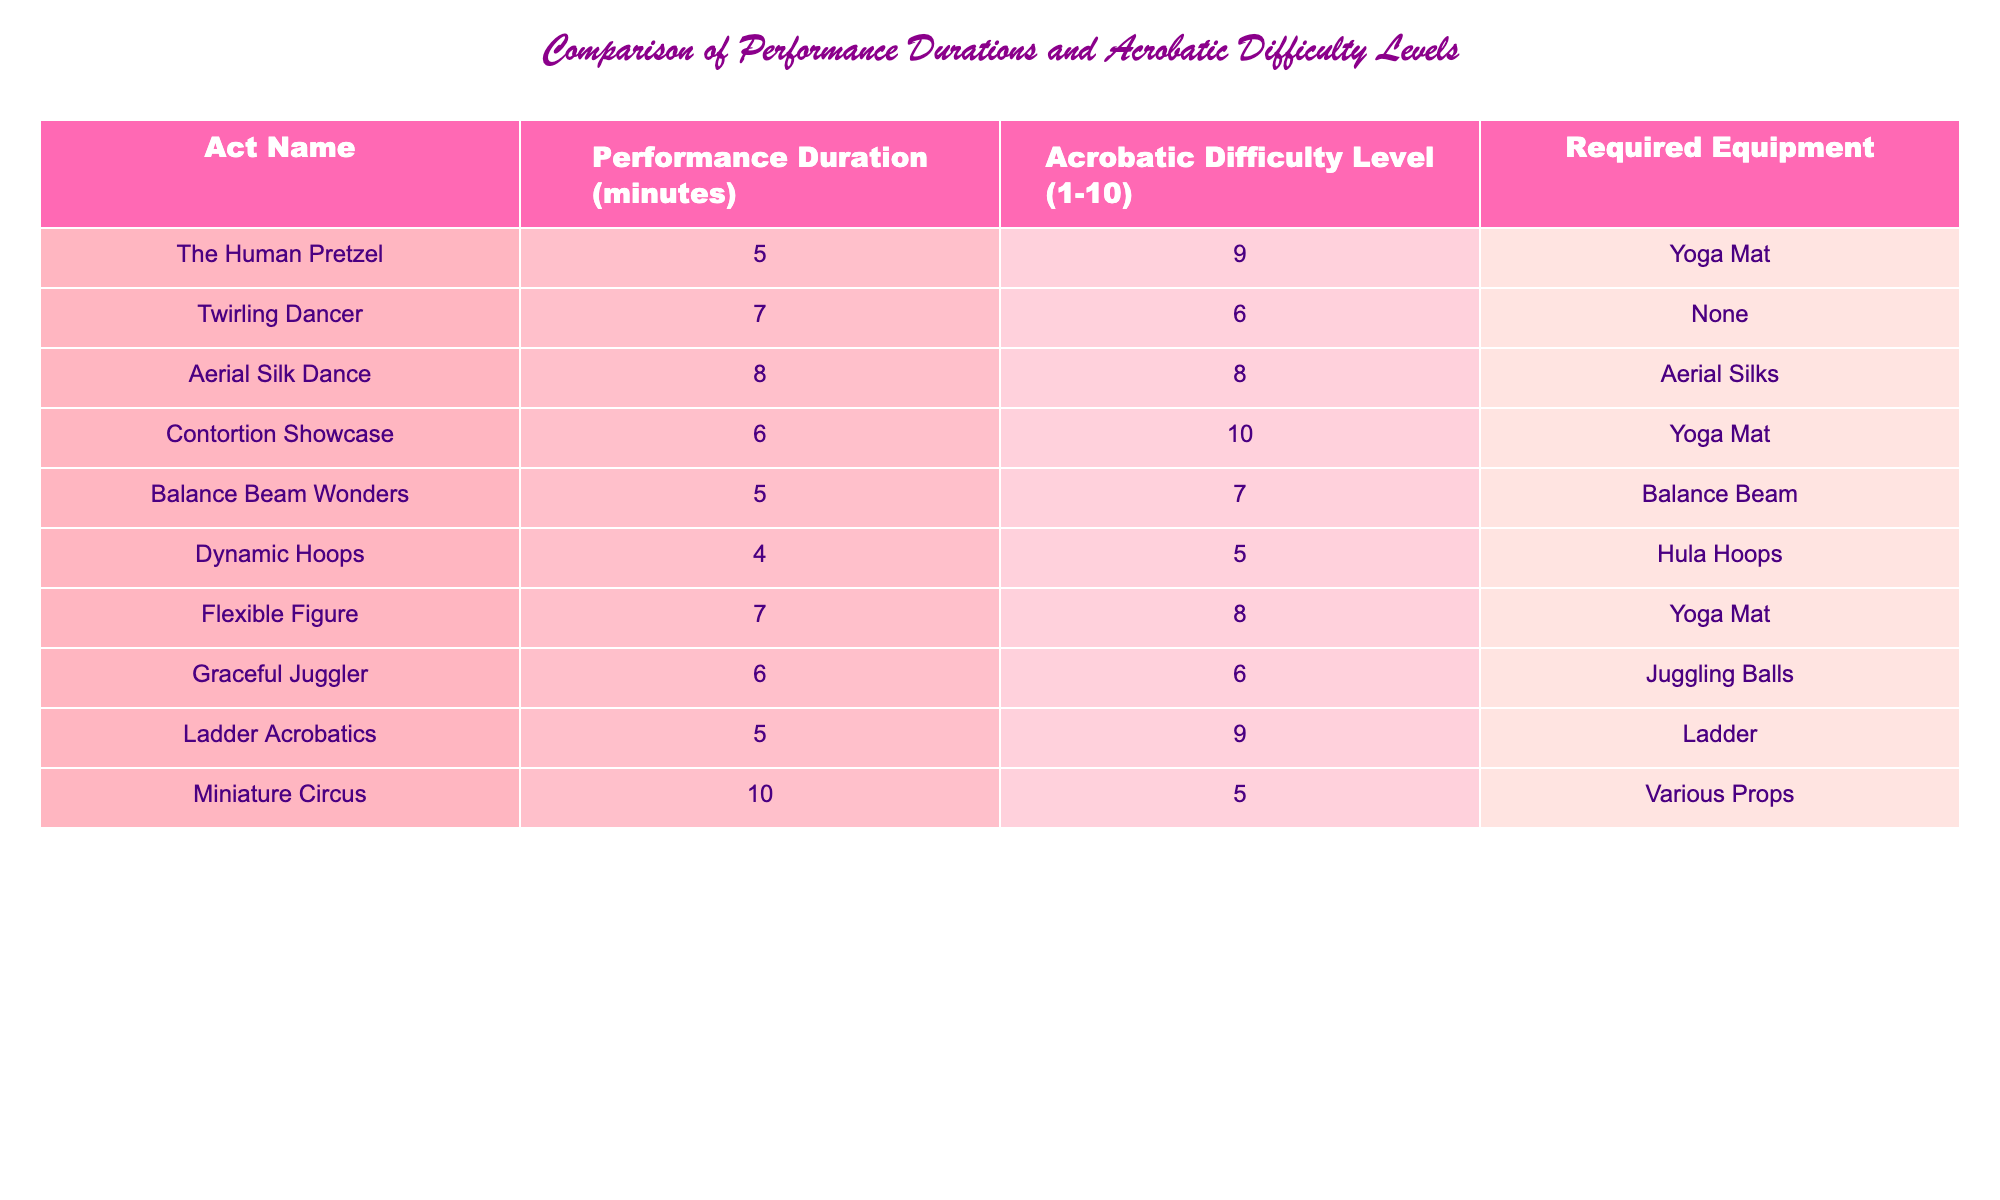What is the performance duration of the "Dynamic Hoops" act? In the table, under the "Performance Duration (minutes)" column, I can find the row corresponding to "Dynamic Hoops" and see that its performance duration is 4 minutes.
Answer: 4 minutes Which act has the highest acrobatic difficulty level? By checking the "Acrobatic Difficulty Level (1-10)" column, I observe that "Contortion Showcase" has the highest value of 10.
Answer: Contortion Showcase How many acts require a yoga mat? I will look for the "Required Equipment" column and count how many times "Yoga Mat" appears. I see it appears for "The Human Pretzel," "Contortion Showcase," and "Flexible Figure." This gives me a total of 3 acts.
Answer: 3 acts What is the average performance duration of all acts? To find the average, I first sum all the performance durations: 5 + 7 + 8 + 6 + 5 + 4 + 7 + 6 + 5 + 10 = 63. Then, I divide by the total number of acts, which is 10. Therefore, the average is 63 / 10 = 6.3 minutes.
Answer: 6.3 minutes Are there any acts that do not require any equipment? I check the "Required Equipment" column and find that "Twirling Dancer" does not list any required equipment. Hence, the answer is yes, there is at least one act that doesn’t require any.
Answer: Yes What is the total acrobatic difficulty level of all acts combined? To find the total difficulty level, I add all the values in the "Acrobatic Difficulty Level (1-10)" column: 9 + 6 + 8 + 10 + 7 + 5 + 8 + 6 + 9 + 5 = 73. Therefore, the combined acrobatic difficulty is 73.
Answer: 73 How many acts have a performance duration of 5 minutes? I look through the "Performance Duration (minutes)" column to count the occurrences of the value "5." I find it applies to "The Human Pretzel," "Balance Beam Wonders," and "Ladder Acrobatics," which totals to 3 acts.
Answer: 3 acts What is the difference in acrobatic difficulty level between the easiest and the hardest act? I identify the easiest act, which is "Miniature Circus" with a difficulty level of 5, and the hardest, which is "Contortion Showcase" with a level of 10. The difference is 10 - 5 = 5.
Answer: 5 